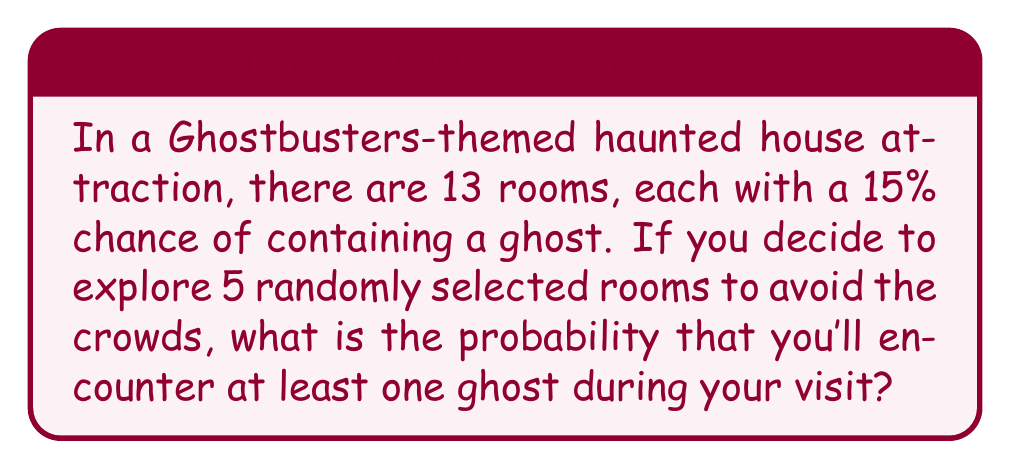Show me your answer to this math problem. Let's approach this step-by-step:

1) First, let's calculate the probability of not encountering a ghost in a single room:
   $P(\text{no ghost in one room}) = 1 - 0.15 = 0.85$

2) Now, for not encountering a ghost in all 5 rooms, we need all 5 rooms to be ghost-free:
   $P(\text{no ghosts in 5 rooms}) = 0.85^5$

3) Let's calculate this:
   $0.85^5 \approx 0.4437$

4) The probability of encountering at least one ghost is the opposite of encountering no ghosts:
   $P(\text{at least one ghost}) = 1 - P(\text{no ghosts in 5 rooms})$

5) Therefore:
   $P(\text{at least one ghost}) = 1 - 0.4437 \approx 0.5563$

6) Converting to a percentage:
   $0.5563 \times 100\% \approx 55.63\%$

Thus, there's approximately a 55.63% chance of encountering at least one ghost during your visit.
Answer: 55.63% 